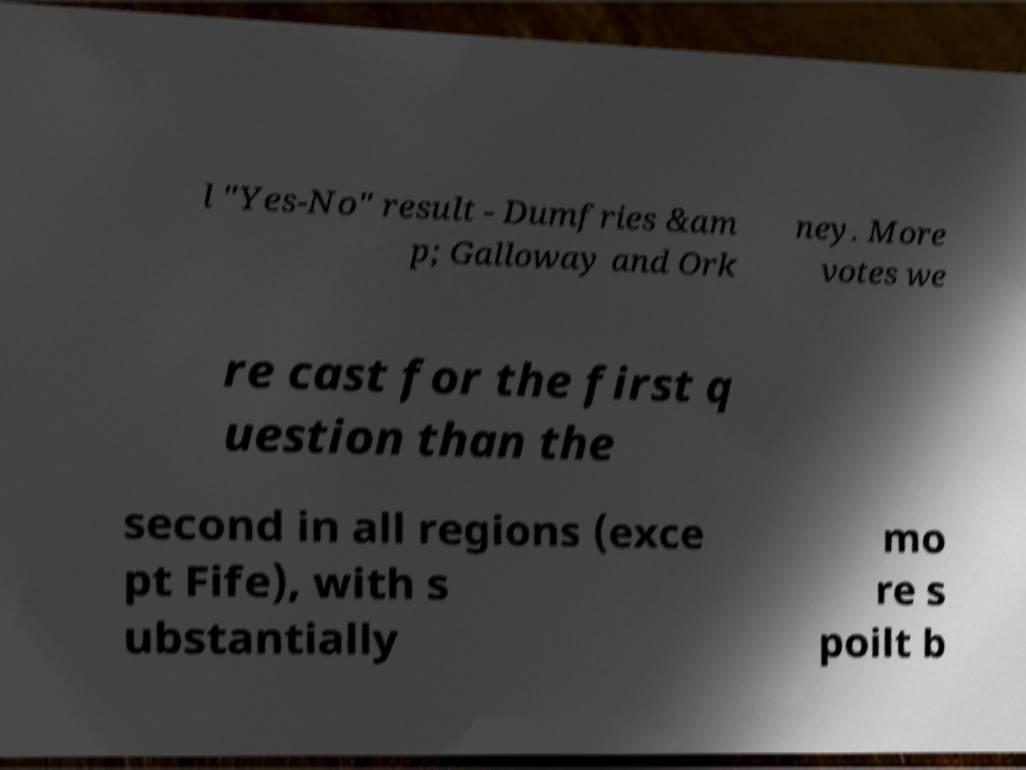Please identify and transcribe the text found in this image. l "Yes-No" result - Dumfries &am p; Galloway and Ork ney. More votes we re cast for the first q uestion than the second in all regions (exce pt Fife), with s ubstantially mo re s poilt b 